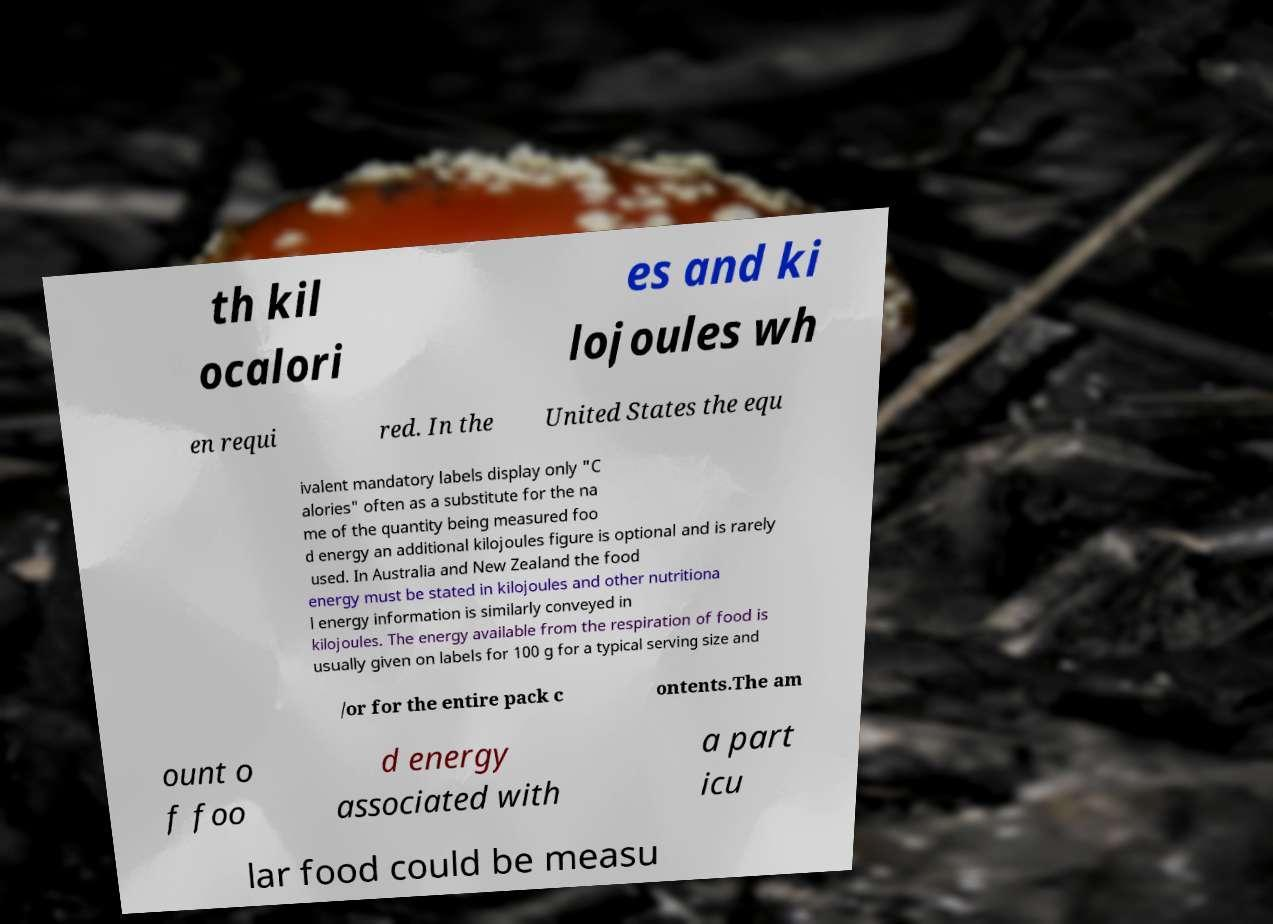Could you extract and type out the text from this image? th kil ocalori es and ki lojoules wh en requi red. In the United States the equ ivalent mandatory labels display only "C alories" often as a substitute for the na me of the quantity being measured foo d energy an additional kilojoules figure is optional and is rarely used. In Australia and New Zealand the food energy must be stated in kilojoules and other nutritiona l energy information is similarly conveyed in kilojoules. The energy available from the respiration of food is usually given on labels for 100 g for a typical serving size and /or for the entire pack c ontents.The am ount o f foo d energy associated with a part icu lar food could be measu 